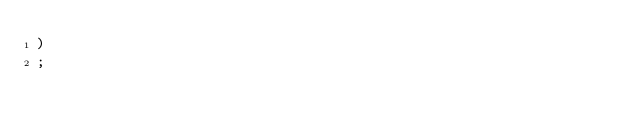Convert code to text. <code><loc_0><loc_0><loc_500><loc_500><_SQL_>)
;
</code> 